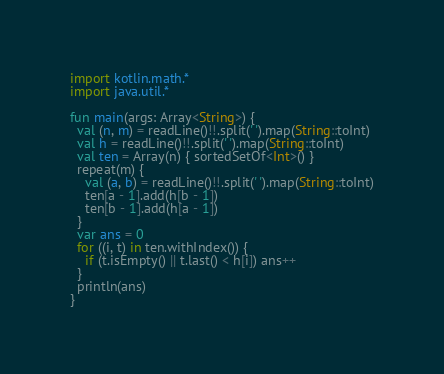<code> <loc_0><loc_0><loc_500><loc_500><_Kotlin_>import kotlin.math.*
import java.util.*

fun main(args: Array<String>) {
  val (n, m) = readLine()!!.split(' ').map(String::toInt)
  val h = readLine()!!.split(' ').map(String::toInt)
  val ten = Array(n) { sortedSetOf<Int>() }
  repeat(m) {
    val (a, b) = readLine()!!.split(' ').map(String::toInt)
    ten[a - 1].add(h[b - 1])
    ten[b - 1].add(h[a - 1])
  }
  var ans = 0
  for ((i, t) in ten.withIndex()) {
    if (t.isEmpty() || t.last() < h[i]) ans++
  }
  println(ans)
}
</code> 